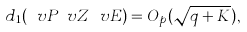<formula> <loc_0><loc_0><loc_500><loc_500>d _ { 1 } ( \ v P _ { \ } v Z \ v E ) = O _ { p } ( \sqrt { q + K } ) ,</formula> 